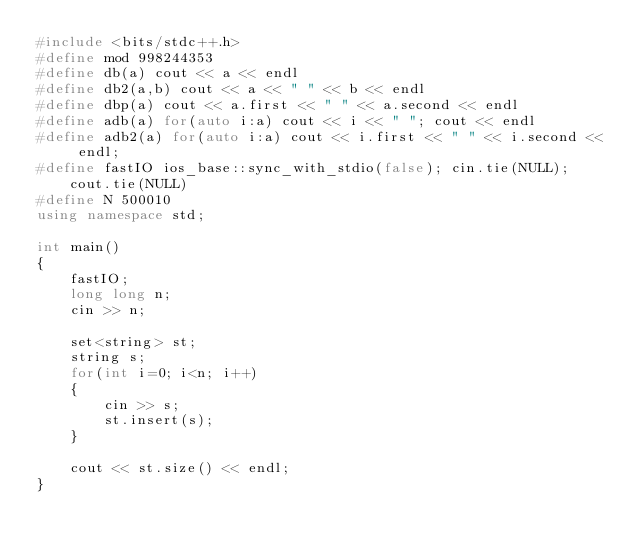Convert code to text. <code><loc_0><loc_0><loc_500><loc_500><_C++_>#include <bits/stdc++.h>
#define mod 998244353
#define db(a) cout << a << endl
#define db2(a,b) cout << a << " " << b << endl
#define dbp(a) cout << a.first << " " << a.second << endl
#define adb(a) for(auto i:a) cout << i << " "; cout << endl
#define adb2(a) for(auto i:a) cout << i.first << " " << i.second << endl;
#define fastIO ios_base::sync_with_stdio(false); cin.tie(NULL); cout.tie(NULL)
#define N 500010
using namespace std;

int main()
{
    fastIO;
    long long n;
    cin >> n;

    set<string> st;
    string s;
    for(int i=0; i<n; i++)
    {
        cin >> s;
        st.insert(s);
    }

    cout << st.size() << endl;
}</code> 